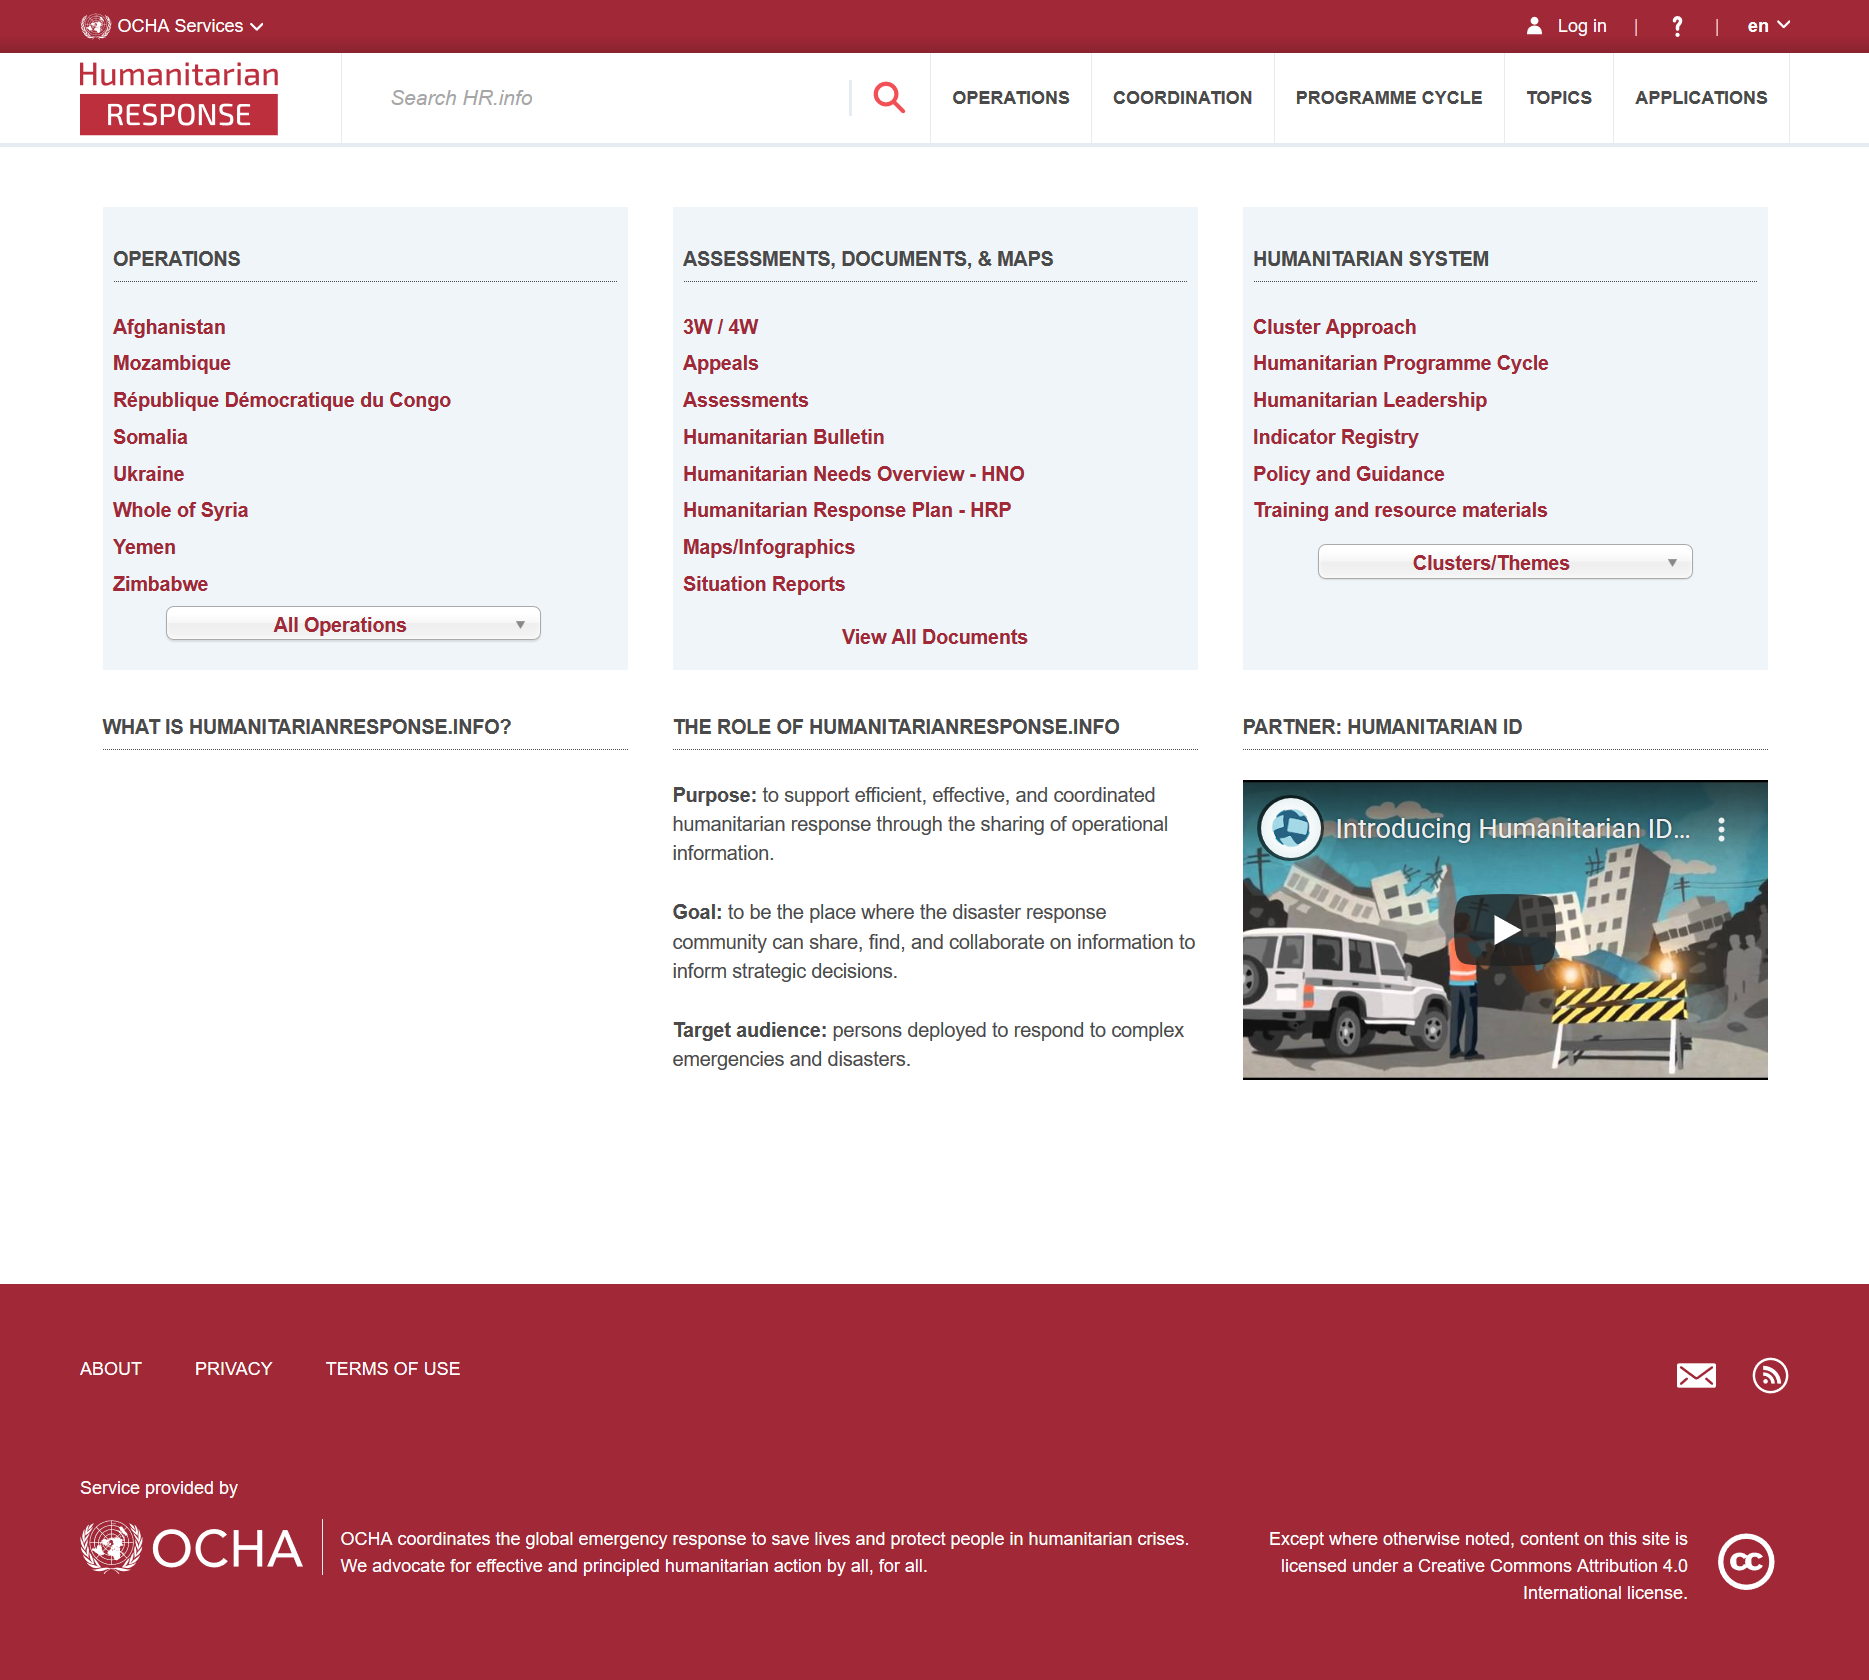Indicate a few pertinent items in this graphic. Humanitarianresponse.info aims to serve as a platform for the disaster response community to exchange, discover, and collaborate on information to facilitate strategic decision-making. Humanitarianreponse.info is a website whose purpose is to facilitate efficient, effective, and coordinated humanitarian response by sharing operational information among responders. The target audience of humanitarianresponse.info comprises individuals deployed to respond to complex emergencies and disasters. 